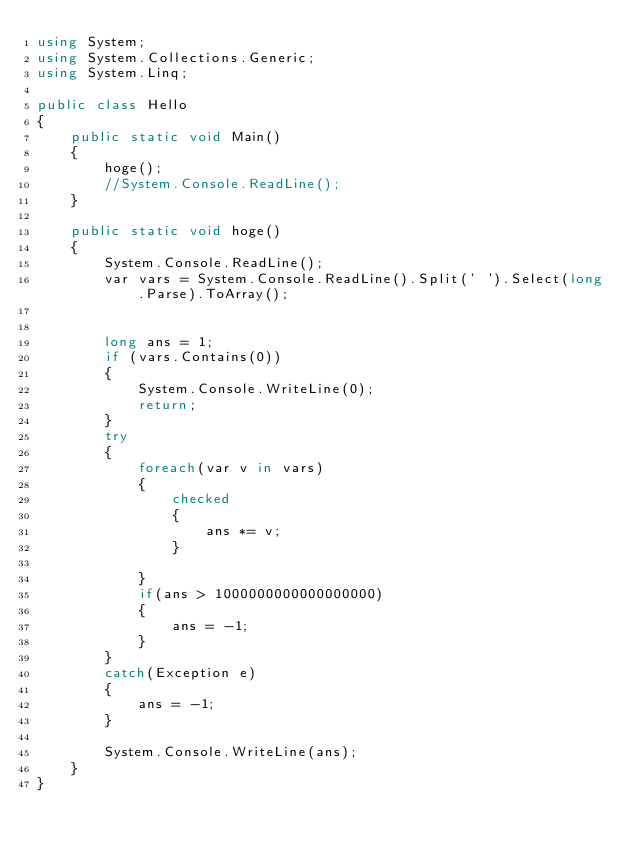<code> <loc_0><loc_0><loc_500><loc_500><_C#_>using System;
using System.Collections.Generic;
using System.Linq;

public class Hello
{
    public static void Main()
    {
        hoge();
        //System.Console.ReadLine();
    }

    public static void hoge()
    {
        System.Console.ReadLine();
        var vars = System.Console.ReadLine().Split(' ').Select(long.Parse).ToArray();


        long ans = 1;
        if (vars.Contains(0))
        {
            System.Console.WriteLine(0);
            return;
        }
        try
        {
            foreach(var v in vars)
            {
                checked
                {
                    ans *= v;
                }
                
            }
            if(ans > 1000000000000000000)
            {
                ans = -1;
            }
        }
        catch(Exception e)
        {
            ans = -1;
        }

        System.Console.WriteLine(ans);
    }
}</code> 